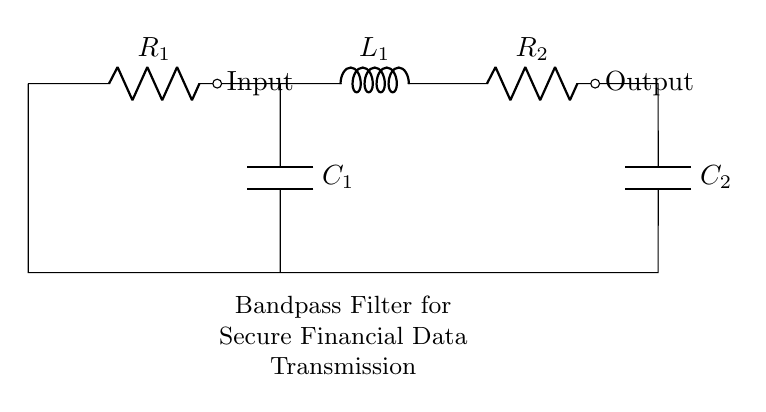What components are present in this circuit? The circuit consists of two resistors, one inductor, and two capacitors, identified as R1, R2, L1, C1, and C2.
Answer: resistors, inductor, capacitors What is the purpose of this bandpass filter circuit? The bandpass filter is designed to allow specific frequency signals to pass, while filtering out unwanted frequencies, which is crucial in secure data transmission.
Answer: secure data transmission How many capacitors are present in the circuit? There are two capacitors, C1 and C2, which are represented in the circuit diagram on the lower left and lower right sides.
Answer: two Which component directly follows the input in the circuit? The input is directly followed by a resistor, which is R1 in this circuit, providing the first element of the filtering process.
Answer: resistor R1 What is the function of the inductor in this bandpass filter? The inductor, L1, plays a role in determining the resonant frequency of the circuit along with the capacitors, helping to create the bandpass characteristics.
Answer: resonant frequency What happens to frequencies outside the passband of this circuit? Frequencies outside the designated passband are attenuated, meaning they are reduced in amplitude, providing higher clarity for the desired data signals.
Answer: attenuated What is the role of the second resistor in this circuit? The second resistor, R2, acts as a load at the output of the filter, influencing the overall impedance and performance of the circuit in signal processing.
Answer: load at output 